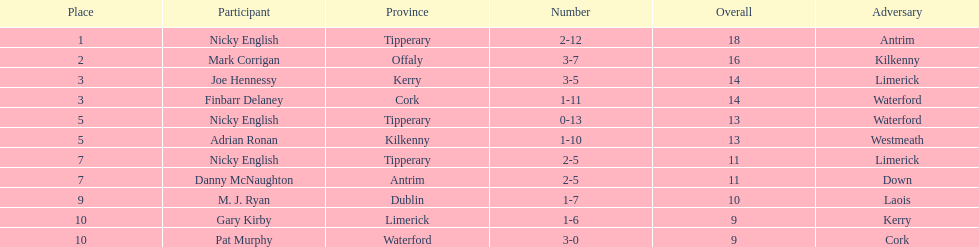What is the first name on the list? Nicky English. 